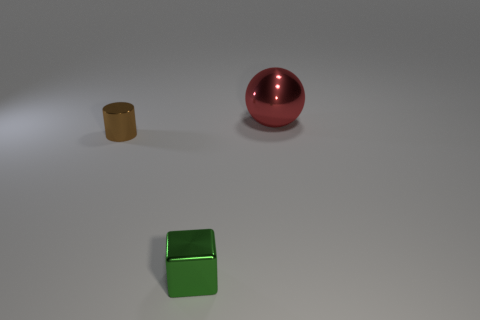How many other things are the same size as the metal ball?
Provide a short and direct response. 0. Does the cylinder have the same material as the sphere?
Your answer should be very brief. Yes. The tiny thing that is in front of the tiny thing behind the tiny metal cube is what color?
Offer a very short reply. Green. What number of small green metallic blocks are in front of the large sphere behind the thing in front of the brown metallic cylinder?
Offer a terse response. 1. Is the number of small metallic objects greater than the number of big red balls?
Your answer should be compact. Yes. How many purple rubber spheres are there?
Provide a succinct answer. 0. There is a tiny shiny object that is in front of the small thing that is left of the small object in front of the small metallic cylinder; what is its shape?
Your answer should be very brief. Cube. Are there fewer tiny brown metal objects to the right of the cylinder than metallic things behind the small green block?
Provide a short and direct response. Yes. There is a small thing that is right of the tiny metallic thing on the left side of the small green shiny cube; what shape is it?
Your answer should be very brief. Cube. Is there a large brown cube that has the same material as the cylinder?
Keep it short and to the point. No. 